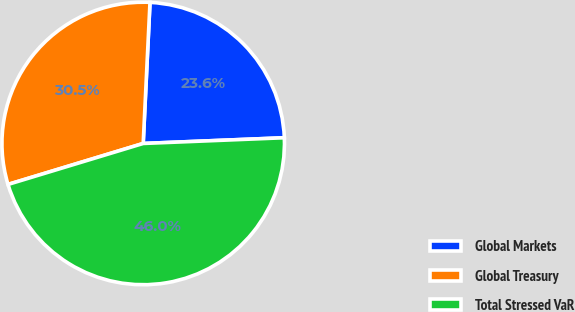<chart> <loc_0><loc_0><loc_500><loc_500><pie_chart><fcel>Global Markets<fcel>Global Treasury<fcel>Total Stressed VaR<nl><fcel>23.59%<fcel>30.45%<fcel>45.96%<nl></chart> 